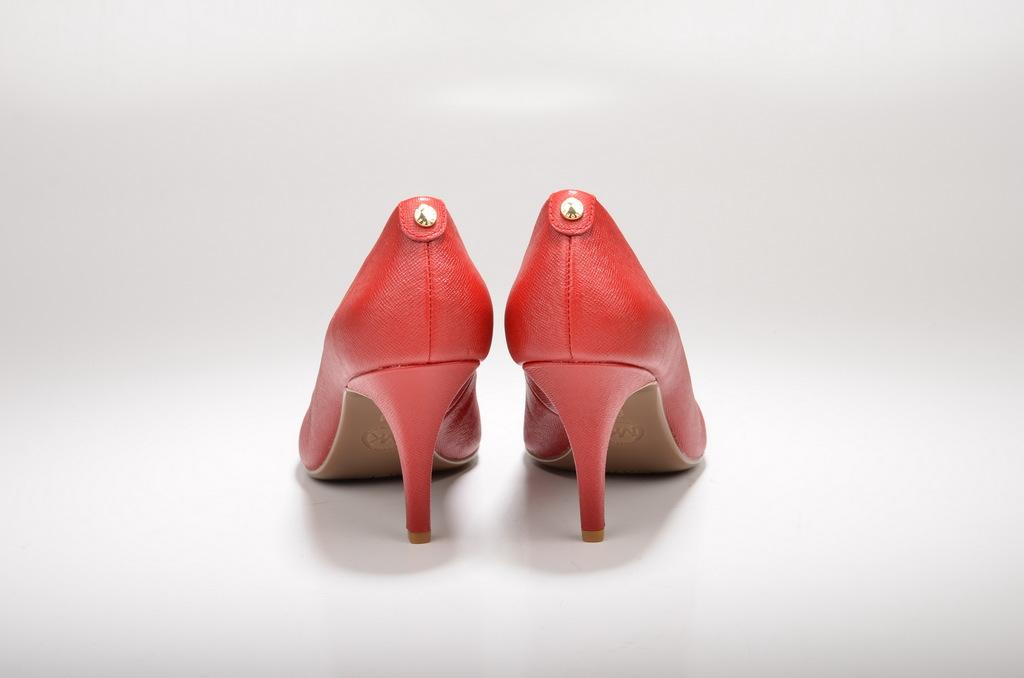What is located in the middle of the image? There are heels in the middle of the image. What color is the background of the image? The background of the image is white. How many pies are visible on the heels in the image? There are no pies present on the heels in the image. Is there a note attached to the heels in the image? There is no mention of a note attached to the heels in the image. 